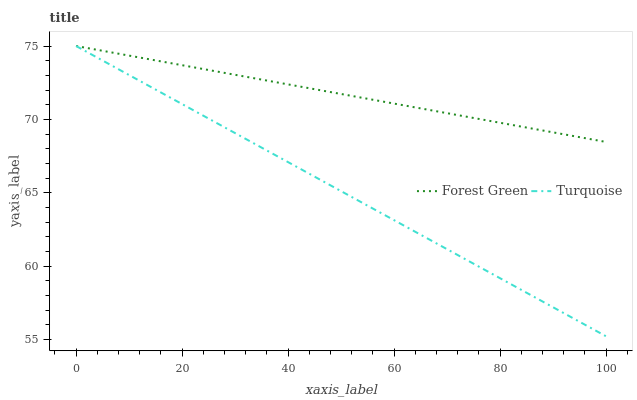Does Turquoise have the minimum area under the curve?
Answer yes or no. Yes. Does Forest Green have the maximum area under the curve?
Answer yes or no. Yes. Does Turquoise have the maximum area under the curve?
Answer yes or no. No. Is Turquoise the smoothest?
Answer yes or no. Yes. Is Forest Green the roughest?
Answer yes or no. Yes. Is Turquoise the roughest?
Answer yes or no. No. 